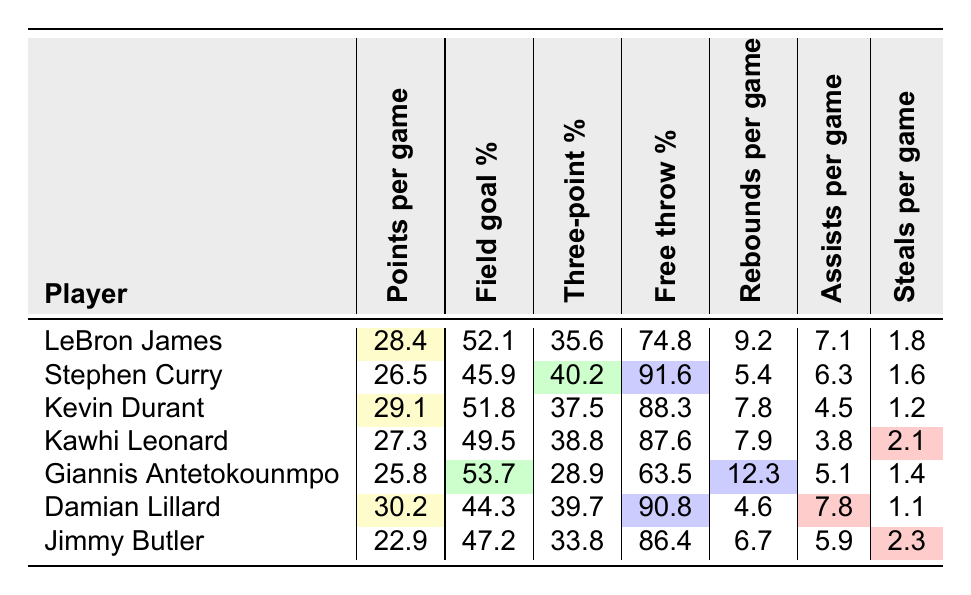What is the free throw percentage of Stephen Curry? Stephen Curry's free throw percentage is listed directly in the table as 91.6.
Answer: 91.6 Which player has the highest points per game in clutch moments? Damian Lillard has the highest points per game, recorded at 30.2, which can be directly found in the "Points per game" column.
Answer: Damian Lillard What is the average field goal percentage of all players listed? To find the average, we add all the field goal percentages: (52.1 + 45.9 + 51.8 + 49.5 + 53.7 + 44.3 + 47.2) = 444.5, then divide by 7 (the number of players), which gives us approximately 63.5.
Answer: Approximately 63.5 Is Jimmy Butler's three-point percentage higher than that of Giannis Antetokounmpo? Jimmy Butler's three-point percentage is 33.8, while Giannis Antetokounmpo's is 28.9; comparing the two shows that Jimmy Butler's percentage is indeed higher.
Answer: Yes Which player has the most rebounds per game? Among the players listed, Giannis Antetokounmpo has the highest rebounds per game at 12.3, as shown in the "Rebounds per game" column.
Answer: Giannis Antetokounmpo If we exclude Damian Lillard's performance, who has the highest points per game among the remaining players? After excluding Damian Lillard, Kevin Durant has the highest points per game at 29.1, which can be found under the "Points per game" column for the other listed players.
Answer: Kevin Durant What is the total number of assists per game from all players? The total assists per game can be calculated by adding all assists: (7.1 + 6.3 + 4.5 + 3.8 + 5.1 + 7.8 + 5.9) = 40.5.
Answer: 40.5 Which player has the best free throw percentage? Stephen Curry has the best free throw percentage at 91.6, as indicated in the "Free throw percentage" column.
Answer: Stephen Curry Are there more players with a points per game greater than 27? Yes, LeBron James (28.4), Kevin Durant (29.1), and Damian Lillard (30.2) have points per game greater than 27, indicating there are three players.
Answer: Yes What is the difference in rebounds per game between Kawhi Leonard and Jimmy Butler? Kawhi Leonard has 7.9 rebounds per game, and Jimmy Butler has 6.7. The difference is calculated as 7.9 - 6.7 = 1.2.
Answer: 1.2 